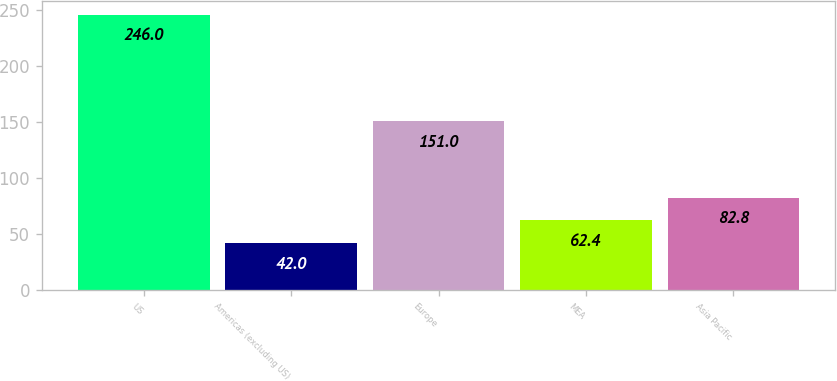Convert chart. <chart><loc_0><loc_0><loc_500><loc_500><bar_chart><fcel>US<fcel>Americas (excluding US)<fcel>Europe<fcel>MEA<fcel>Asia Pacific<nl><fcel>246<fcel>42<fcel>151<fcel>62.4<fcel>82.8<nl></chart> 